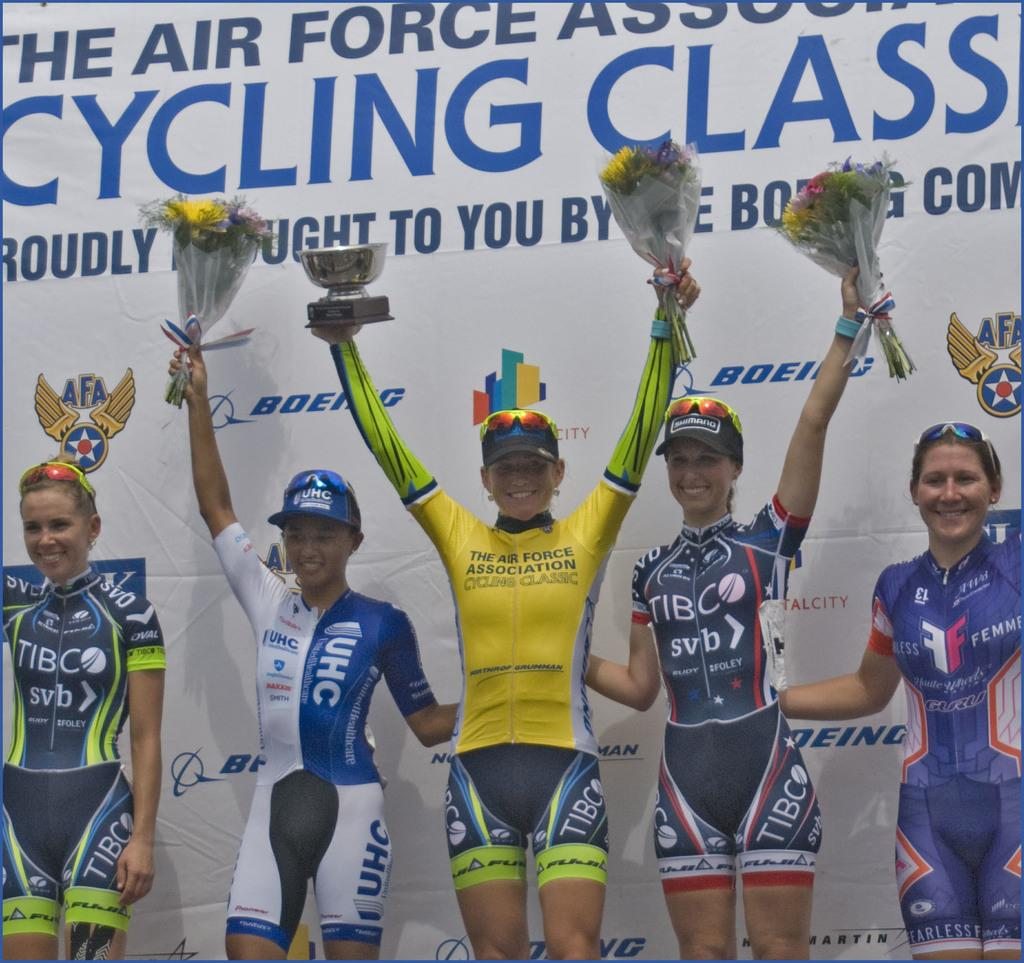Provide a one-sentence caption for the provided image. The posted behind the winners reads Cycling Class. 